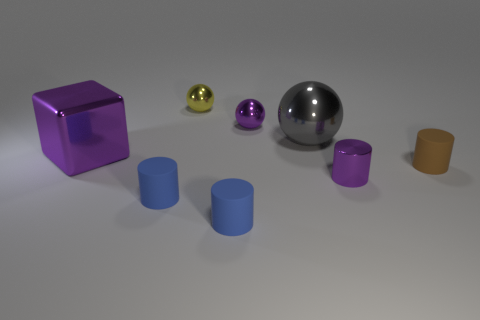Subtract all big spheres. How many spheres are left? 2 Subtract all gray blocks. How many blue cylinders are left? 2 Add 2 purple metal objects. How many objects exist? 10 Subtract all yellow spheres. How many spheres are left? 2 Subtract 1 cylinders. How many cylinders are left? 3 Subtract all blocks. How many objects are left? 7 Subtract 0 green blocks. How many objects are left? 8 Subtract all green balls. Subtract all gray cylinders. How many balls are left? 3 Subtract all large red cylinders. Subtract all gray metal objects. How many objects are left? 7 Add 4 brown objects. How many brown objects are left? 5 